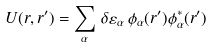<formula> <loc_0><loc_0><loc_500><loc_500>U ( { r } , { r } ^ { \prime } ) = \sum _ { \alpha } \, \delta \varepsilon _ { \alpha } \, \phi _ { \alpha } ( { r } ^ { \prime } ) \phi ^ { * } _ { \alpha } ( { r } ^ { \prime } ) \,</formula> 